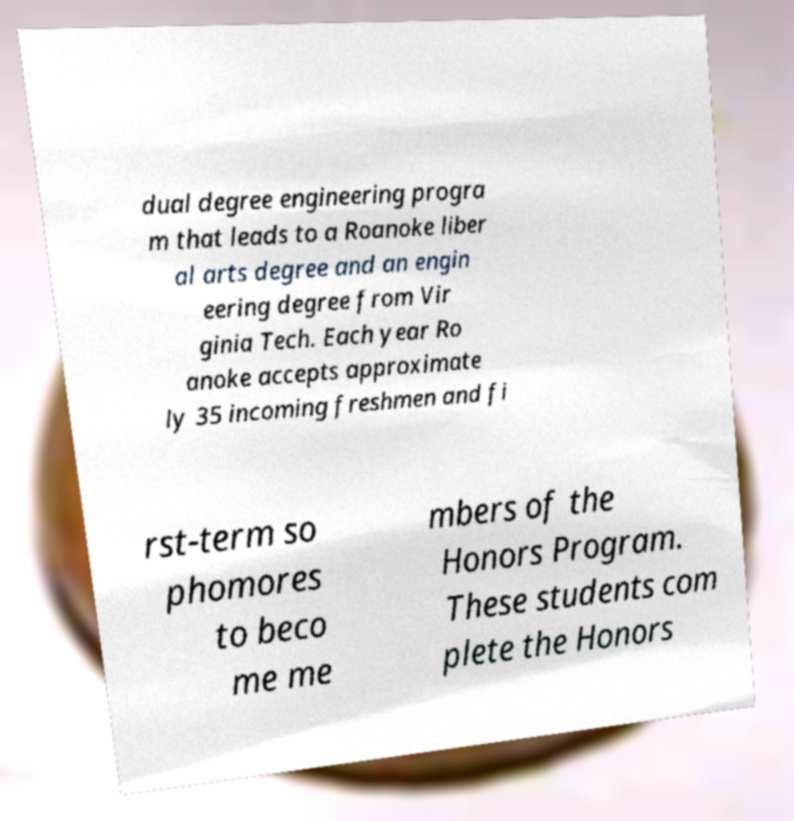There's text embedded in this image that I need extracted. Can you transcribe it verbatim? dual degree engineering progra m that leads to a Roanoke liber al arts degree and an engin eering degree from Vir ginia Tech. Each year Ro anoke accepts approximate ly 35 incoming freshmen and fi rst-term so phomores to beco me me mbers of the Honors Program. These students com plete the Honors 